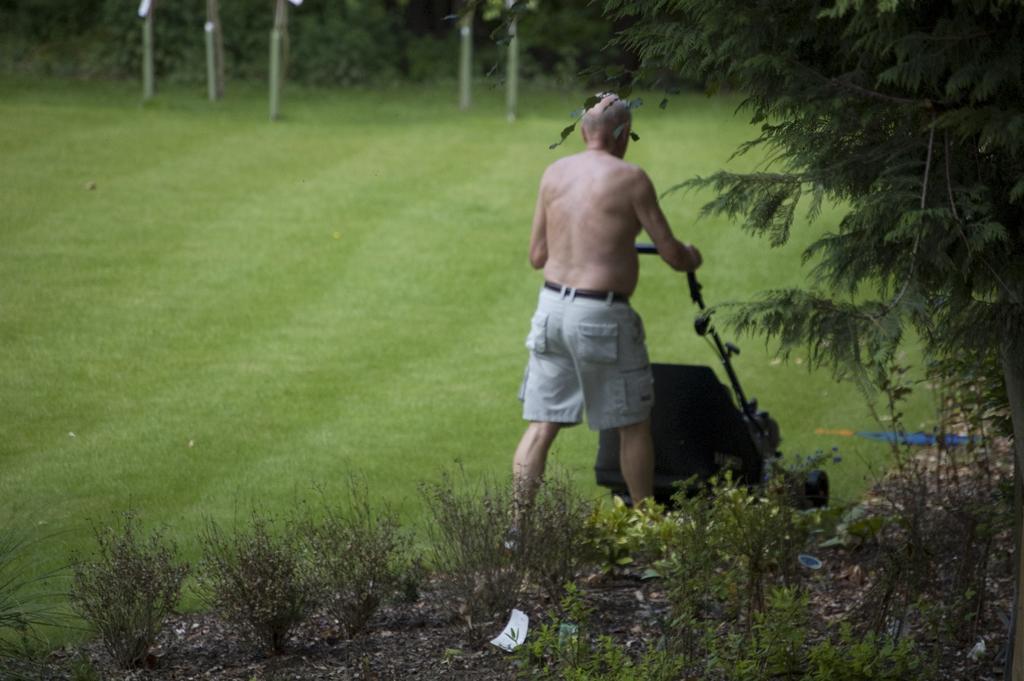Can you describe this image briefly? This is the man holding a lawn mower and walking. Here is the grass. These are the plants and trees. 